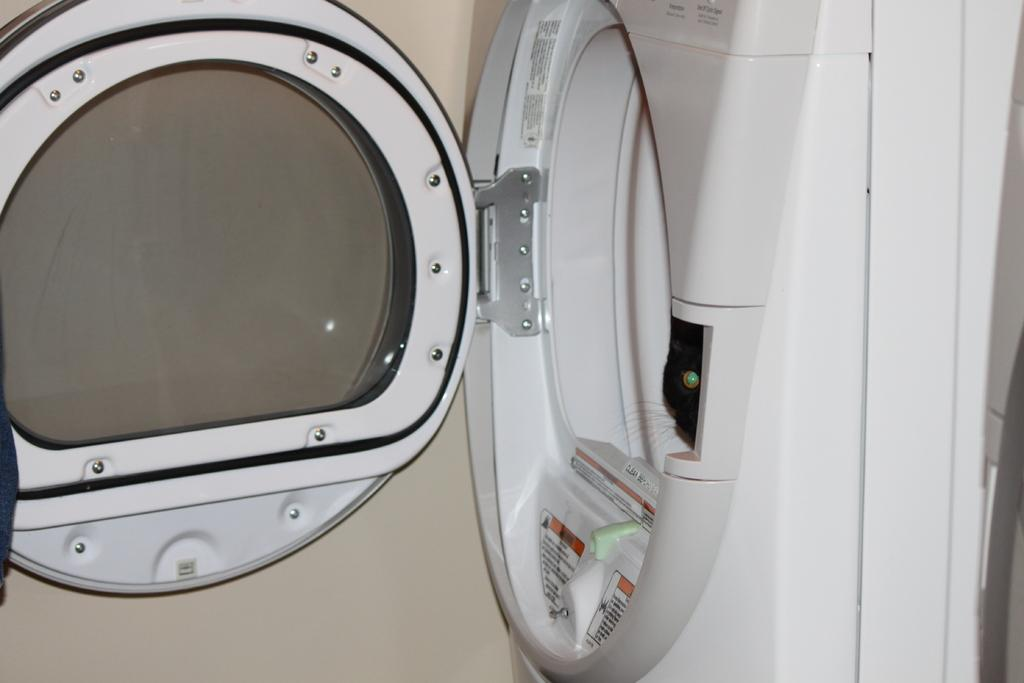What is the main subject in the image? There is a machine in the image. Can you describe the setting of the image? There is a wall visible in the background of the image. What type of account is required to use the machine in the image? There is no mention of an account or any requirement to use the machine in the image. 